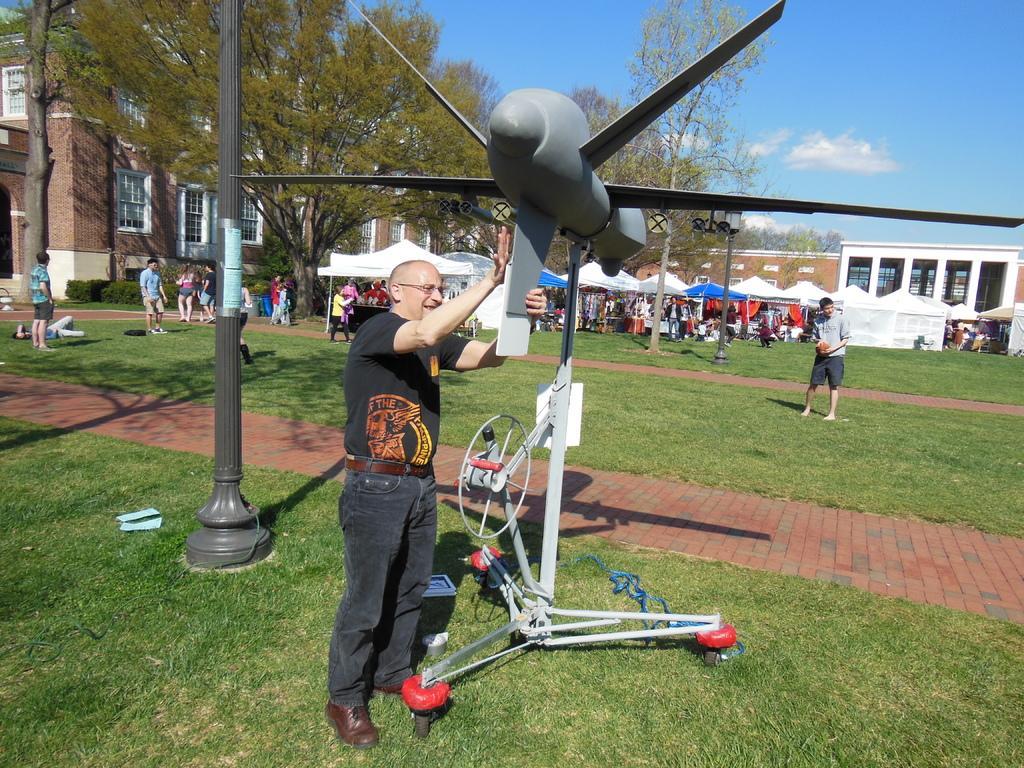Describe this image in one or two sentences. In this image there is a person standing and holding an demo airplane , and there are stalls, buildings, trees, group of people, and in the background there is sky. 